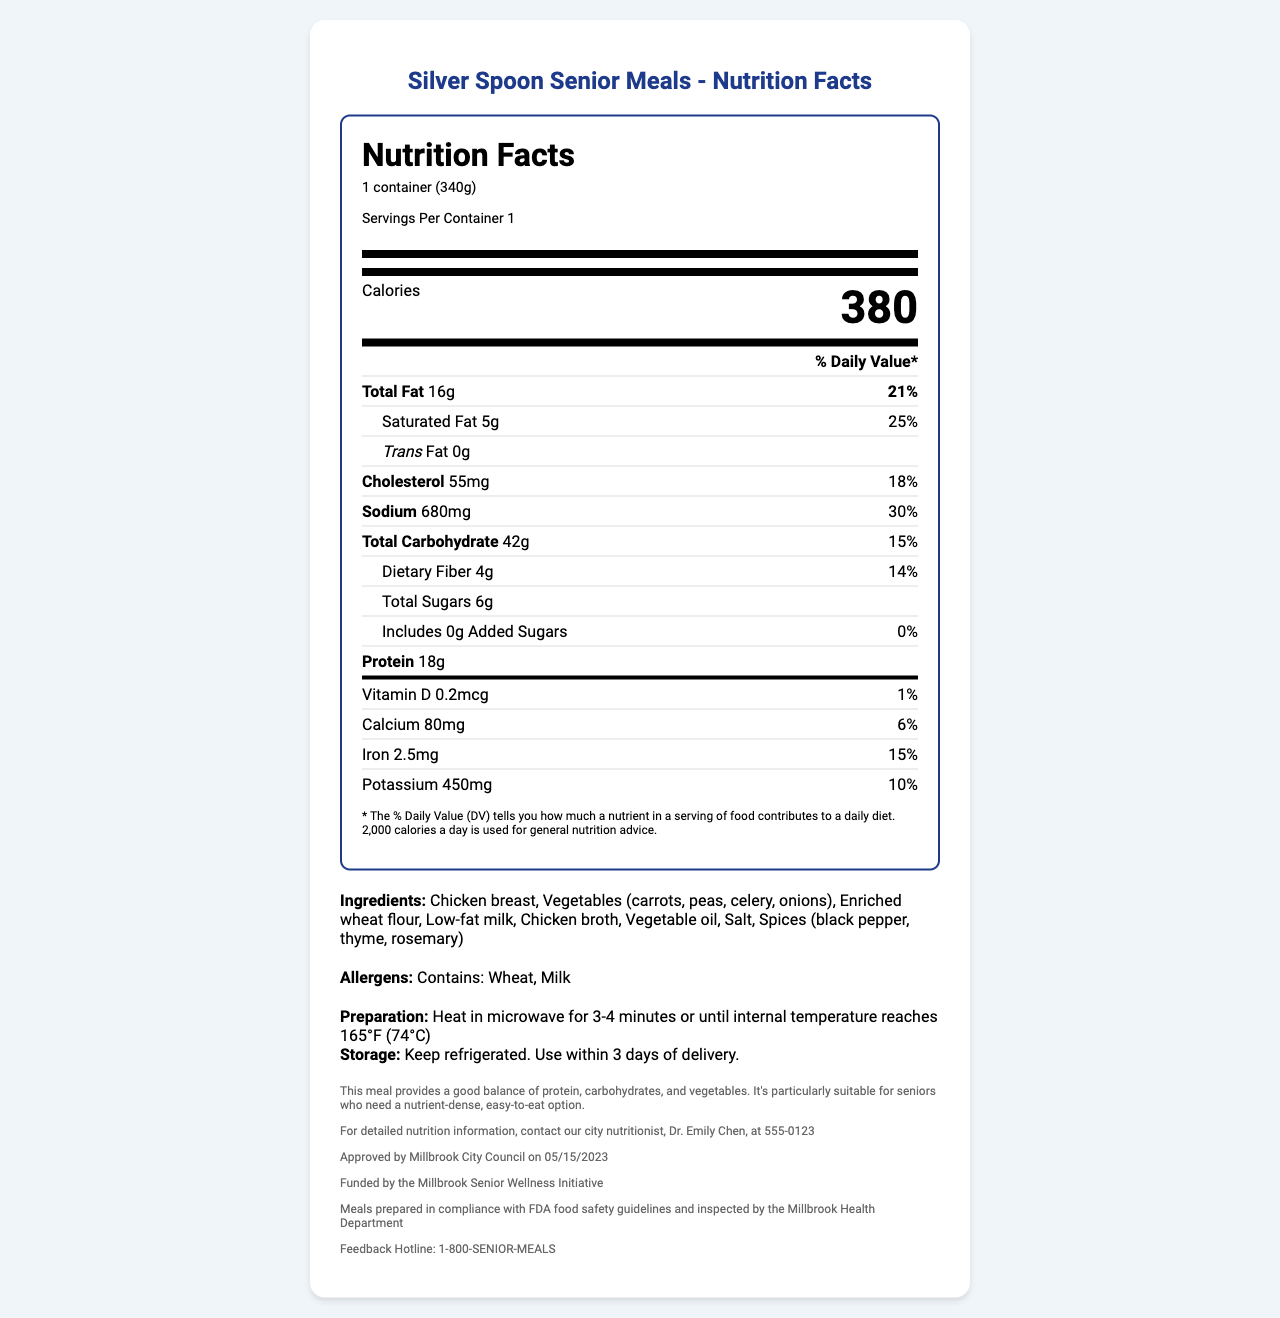what is the serving size for Hearty Chicken Pot Pie? The document states that the serving size for Hearty Chicken Pot Pie is 1 container, which weighs 340 grams.
Answer: 1 container (340g) how many calories are in one serving of the Hearty Chicken Pot Pie? The document lists the calories per serving as 380 in bold text under the "Calories" section.
Answer: 380 what is the total amount of fat per serving? The document shows that the total fat per serving is 16 grams in the "Total Fat" section.
Answer: 16g what percentage of the daily value is the sodium content? According to the document, the sodium content is 680mg, which amounts to 30% of the daily value.
Answer: 30% which ingredient(s) could cause an allergic reaction? The allergens section specifies that the meal contains wheat and milk.
Answer: Wheat, Milk how much protein does one serving provide? A. 10g B. 18g C. 20g D. 25g The document states that one serving provides 18 grams of protein.
Answer: B which nutrient has the highest daily value percentage? A. Saturated Fat B. Cholesterol C. Sodium D. Dietary Fiber Sodium has the highest daily value percentage at 30%.
Answer: C is there any added sugar in the meal? The document indicates that there are 0 grams of added sugars.
Answer: No is the meal suitable for vegetarians? The meal contains chicken breast, as listed in the ingredients, making it unsuitable for vegetarians.
Answer: No summarize the main idea of the document. The summary captures the primary focus of the document, outlining the nutritional content, ingredients, and additional relevant information about the meal provided.
Answer: The document provides the nutrition facts for the "Hearty Chicken Pot Pie" meal by Silver Spoon Senior Meals. It details serving size, calories, nutritional content, ingredients, allergens, preparation and storage instructions, along with meal planning notes and contact information. The meal is aimed at providing seniors with a nutrient-dense, balanced option. what is the address of the city's main office? The document does not provide any information about the address of the city's main office.
Answer: Cannot be determined 